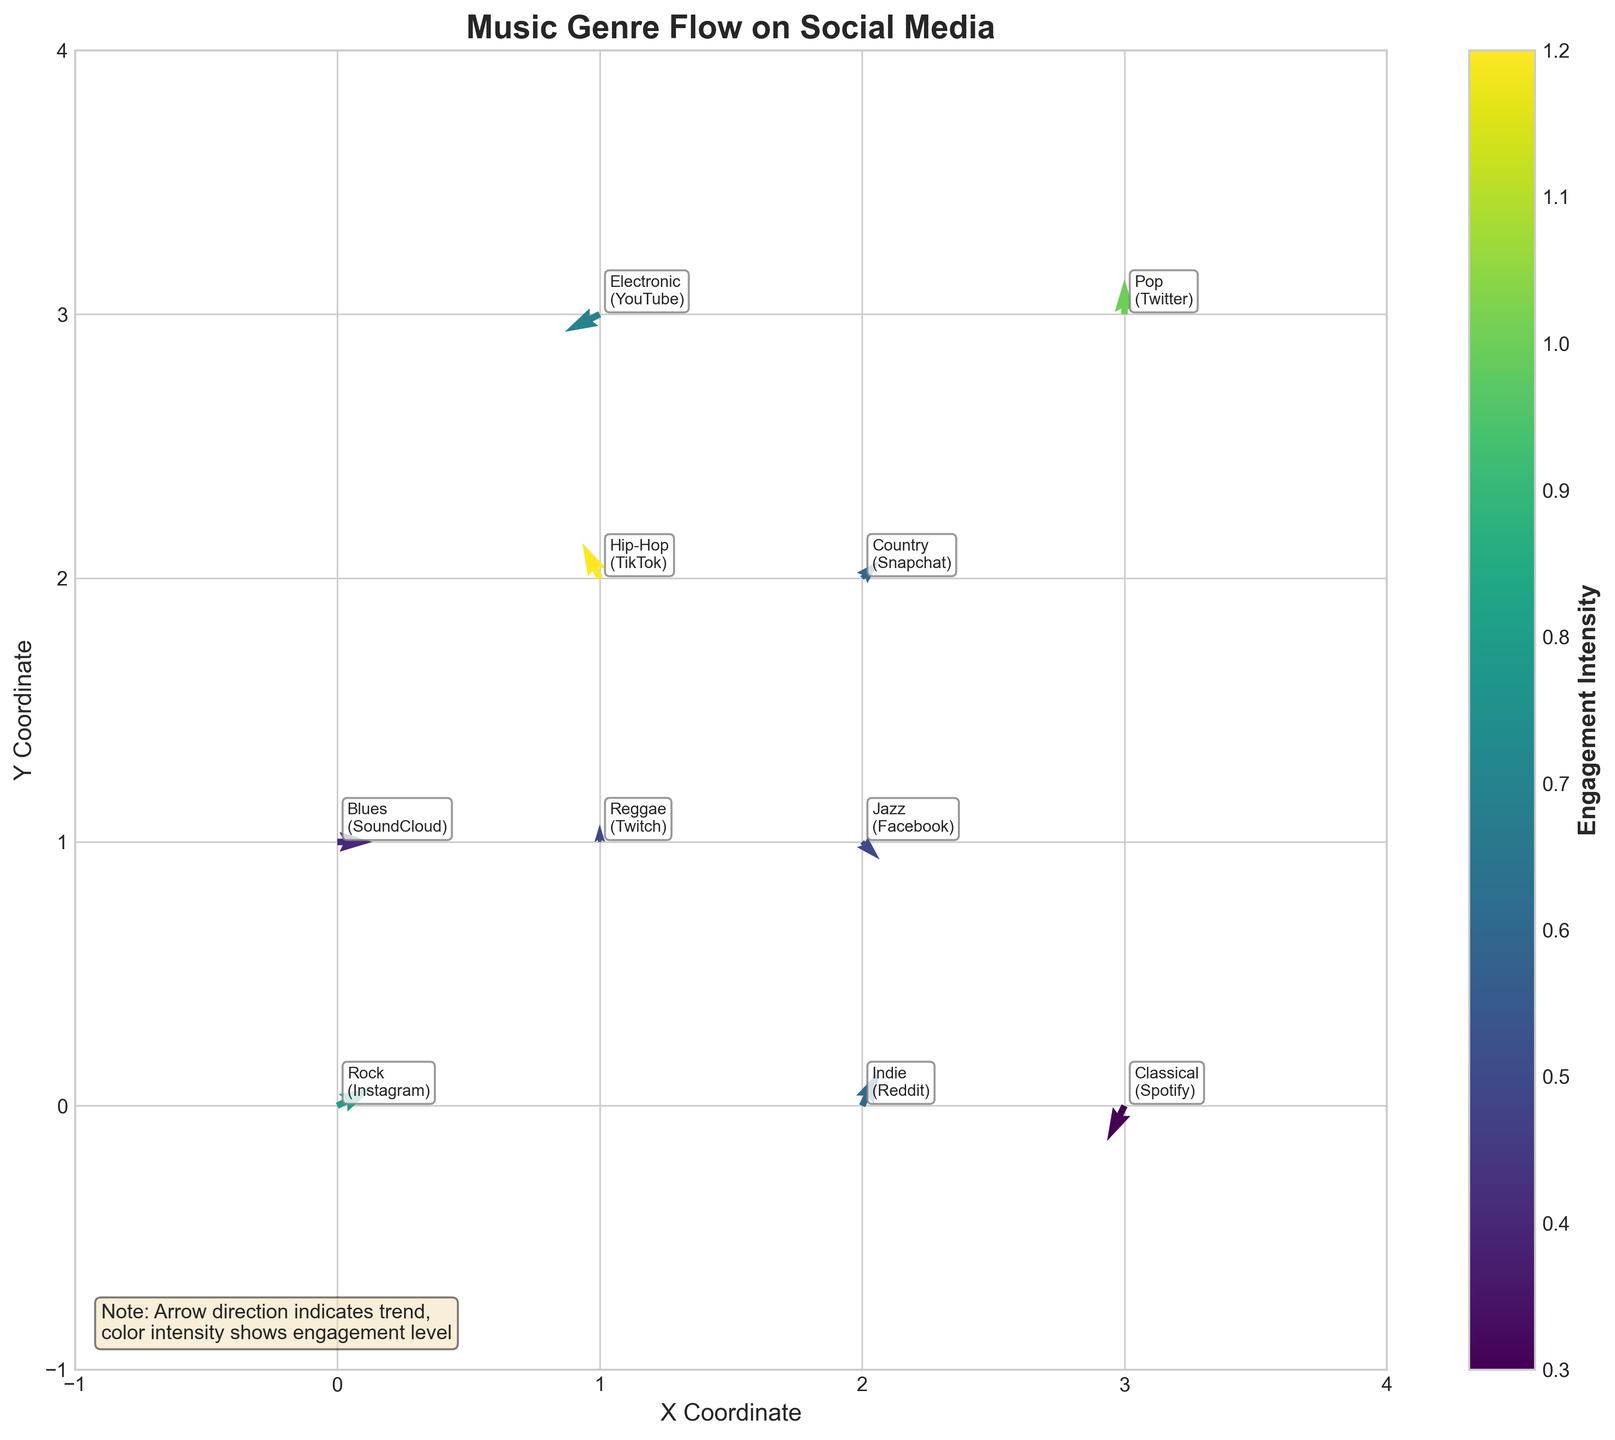What is the title of the figure? The title of the figure is displayed at the top and is written in a larger font size and bold. It summarizes the content of the chart.
Answer: Music Genre Flow on Social Media What colors represent the engagement intensity on the plot? The colorbar on the right side of the figure shows a gradient from light to dark colors. Each color indicates a level of engagement intensity, with lighter colors representing lower intensity and darker colors representing higher intensity.
Answer: Gradient from light to dark What is the engagement intensity for the Instagram-Rock data point? The labels next to the arrows contain both the genre and platform. Looking for Rock on Instagram, we find a light color arrow near (0,0), referring to the colorbar to relate the light color shows 0.8 intensity.
Answer: 0.8 Which genre-platform combination has the highest engagement intensity? Look for the darkest arrow, which indicates the highest intensity. The darkest arrow is found at (1, 2), representing Hip-Hop on TikTok with an intensity of 1.2 as shown in the colorbar.
Answer: Hip-Hop on TikTok How many arrows are pointing to the right? Count the arrows where the directional trend (u component) is greater than 0. Examine each arrow direction visually: Rock-Instagram, Blues-SoundCloud, Indie-Reddit, and Country-Snapchat point right.
Answer: Four What combination has similar x and y directional trends (u and v values)? Inspect arrows where both u and v values are close or equal. The Jazz-Facebook arrow shows (1, -1), but the Pop-Twitter arrow (0, 2) does not. The combination where both values add up to the same is Country-Snapchat (1, 1).
Answer: Country-Snapchat Which platform has the lowest engagement intensity? Find the lightest colored arrow. Classical-Spotify at (3, 0) is nearly white. Referencing the colorbar, this shows the intensity of 0.3.
Answer: Spotify (Classical) Which genre shows an upward trend? Look for arrows where v component is positive, indicating an upward movement: Rock-Instagram, Hip-Hop-TikTok, Pop-Twitter, and Indie-Reddit show this trend.
Answer: Rock, Hip-Hop, Pop, Indie Describe the directional trend for Reggae on Twitch. Find the Reggae-Twitch data point. The arrow from (1,1) points upwards with v value positive (0,1). The u component is zero, showing no horizontal movement.
Answer: Upward Which genre on YouTube shows the downward-left trend? Find arrows pointing down and left. From YouTube-Electronic near (1,3) with (-2,-1), pointing bottom-left.
Answer: Electronic (YouTube) Which genres are more popular on platforms with downward trends? Check arrows trending downward (v component less than 0). Electronic-YouTube (-2,-1) near (1,3) and Classical-Spotify (-1,-2) near (3,0).
Answer: Electronic, Classical Are there any platforms where genres have a perfectly horizontal trend? Perfect horizontal indicates pure lateral movement (v=0). Blues-SoundCloud u=2, v=0 at (0,1) indicates this.
Answer: SoundCloud (Blues) 